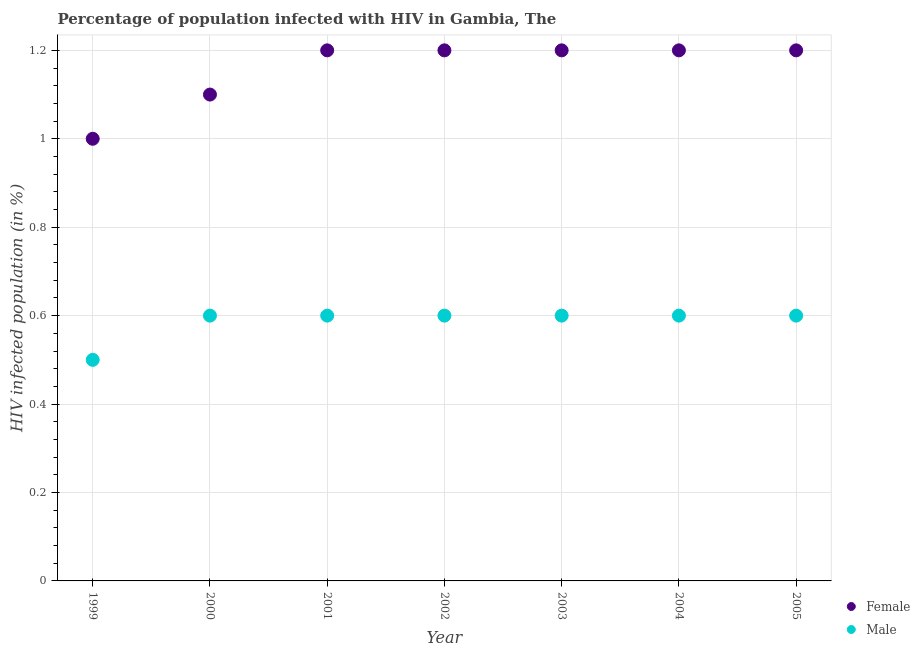How many different coloured dotlines are there?
Offer a very short reply. 2. Is the number of dotlines equal to the number of legend labels?
Offer a very short reply. Yes. In which year was the percentage of males who are infected with hiv minimum?
Make the answer very short. 1999. What is the difference between the percentage of females who are infected with hiv in 1999 and that in 2000?
Provide a succinct answer. -0.1. What is the average percentage of males who are infected with hiv per year?
Offer a very short reply. 0.59. What is the difference between the highest and the second highest percentage of females who are infected with hiv?
Provide a succinct answer. 0. What is the difference between the highest and the lowest percentage of females who are infected with hiv?
Your answer should be compact. 0.2. In how many years, is the percentage of males who are infected with hiv greater than the average percentage of males who are infected with hiv taken over all years?
Your answer should be compact. 6. Is the sum of the percentage of females who are infected with hiv in 1999 and 2000 greater than the maximum percentage of males who are infected with hiv across all years?
Your answer should be compact. Yes. Is the percentage of females who are infected with hiv strictly greater than the percentage of males who are infected with hiv over the years?
Your response must be concise. Yes. How many dotlines are there?
Ensure brevity in your answer.  2. Does the graph contain grids?
Give a very brief answer. Yes. Where does the legend appear in the graph?
Your response must be concise. Bottom right. How many legend labels are there?
Keep it short and to the point. 2. What is the title of the graph?
Offer a very short reply. Percentage of population infected with HIV in Gambia, The. Does "Food" appear as one of the legend labels in the graph?
Offer a terse response. No. What is the label or title of the X-axis?
Offer a very short reply. Year. What is the label or title of the Y-axis?
Keep it short and to the point. HIV infected population (in %). What is the HIV infected population (in %) of Male in 2001?
Ensure brevity in your answer.  0.6. What is the HIV infected population (in %) in Female in 2002?
Offer a very short reply. 1.2. What is the HIV infected population (in %) of Male in 2002?
Provide a succinct answer. 0.6. What is the HIV infected population (in %) in Female in 2003?
Provide a succinct answer. 1.2. What is the HIV infected population (in %) of Male in 2003?
Provide a short and direct response. 0.6. What is the HIV infected population (in %) in Male in 2004?
Ensure brevity in your answer.  0.6. Across all years, what is the maximum HIV infected population (in %) in Male?
Offer a terse response. 0.6. Across all years, what is the minimum HIV infected population (in %) of Female?
Provide a short and direct response. 1. What is the total HIV infected population (in %) of Female in the graph?
Your response must be concise. 8.1. What is the total HIV infected population (in %) in Male in the graph?
Your answer should be compact. 4.1. What is the difference between the HIV infected population (in %) in Female in 1999 and that in 2000?
Give a very brief answer. -0.1. What is the difference between the HIV infected population (in %) in Male in 1999 and that in 2000?
Give a very brief answer. -0.1. What is the difference between the HIV infected population (in %) of Female in 1999 and that in 2001?
Your response must be concise. -0.2. What is the difference between the HIV infected population (in %) in Male in 1999 and that in 2001?
Your answer should be very brief. -0.1. What is the difference between the HIV infected population (in %) of Male in 1999 and that in 2002?
Offer a terse response. -0.1. What is the difference between the HIV infected population (in %) of Female in 1999 and that in 2003?
Ensure brevity in your answer.  -0.2. What is the difference between the HIV infected population (in %) of Male in 1999 and that in 2003?
Your answer should be very brief. -0.1. What is the difference between the HIV infected population (in %) of Female in 1999 and that in 2004?
Provide a succinct answer. -0.2. What is the difference between the HIV infected population (in %) in Male in 1999 and that in 2004?
Offer a terse response. -0.1. What is the difference between the HIV infected population (in %) in Female in 1999 and that in 2005?
Your response must be concise. -0.2. What is the difference between the HIV infected population (in %) in Female in 2000 and that in 2002?
Provide a short and direct response. -0.1. What is the difference between the HIV infected population (in %) in Male in 2000 and that in 2002?
Provide a short and direct response. 0. What is the difference between the HIV infected population (in %) in Male in 2000 and that in 2004?
Ensure brevity in your answer.  0. What is the difference between the HIV infected population (in %) of Male in 2000 and that in 2005?
Offer a very short reply. 0. What is the difference between the HIV infected population (in %) of Female in 2001 and that in 2003?
Provide a short and direct response. 0. What is the difference between the HIV infected population (in %) in Male in 2001 and that in 2003?
Your answer should be compact. 0. What is the difference between the HIV infected population (in %) of Male in 2001 and that in 2004?
Provide a succinct answer. 0. What is the difference between the HIV infected population (in %) of Female in 2001 and that in 2005?
Keep it short and to the point. 0. What is the difference between the HIV infected population (in %) of Male in 2001 and that in 2005?
Keep it short and to the point. 0. What is the difference between the HIV infected population (in %) of Male in 2002 and that in 2003?
Make the answer very short. 0. What is the difference between the HIV infected population (in %) in Female in 2002 and that in 2004?
Keep it short and to the point. 0. What is the difference between the HIV infected population (in %) in Male in 2002 and that in 2004?
Your response must be concise. 0. What is the difference between the HIV infected population (in %) of Male in 2002 and that in 2005?
Provide a short and direct response. 0. What is the difference between the HIV infected population (in %) of Female in 2003 and that in 2004?
Offer a very short reply. 0. What is the difference between the HIV infected population (in %) of Male in 2003 and that in 2004?
Your answer should be compact. 0. What is the difference between the HIV infected population (in %) in Female in 2004 and that in 2005?
Ensure brevity in your answer.  0. What is the difference between the HIV infected population (in %) of Male in 2004 and that in 2005?
Your answer should be very brief. 0. What is the difference between the HIV infected population (in %) in Female in 1999 and the HIV infected population (in %) in Male in 2001?
Provide a succinct answer. 0.4. What is the difference between the HIV infected population (in %) of Female in 2000 and the HIV infected population (in %) of Male in 2003?
Offer a very short reply. 0.5. What is the difference between the HIV infected population (in %) in Female in 2001 and the HIV infected population (in %) in Male in 2002?
Provide a short and direct response. 0.6. What is the difference between the HIV infected population (in %) of Female in 2001 and the HIV infected population (in %) of Male in 2003?
Offer a terse response. 0.6. What is the difference between the HIV infected population (in %) in Female in 2001 and the HIV infected population (in %) in Male in 2004?
Your answer should be compact. 0.6. What is the difference between the HIV infected population (in %) of Female in 2002 and the HIV infected population (in %) of Male in 2004?
Offer a very short reply. 0.6. What is the difference between the HIV infected population (in %) of Female in 2003 and the HIV infected population (in %) of Male in 2004?
Your answer should be compact. 0.6. What is the difference between the HIV infected population (in %) of Female in 2003 and the HIV infected population (in %) of Male in 2005?
Give a very brief answer. 0.6. What is the difference between the HIV infected population (in %) of Female in 2004 and the HIV infected population (in %) of Male in 2005?
Make the answer very short. 0.6. What is the average HIV infected population (in %) of Female per year?
Your answer should be compact. 1.16. What is the average HIV infected population (in %) in Male per year?
Offer a terse response. 0.59. In the year 1999, what is the difference between the HIV infected population (in %) of Female and HIV infected population (in %) of Male?
Keep it short and to the point. 0.5. In the year 2001, what is the difference between the HIV infected population (in %) in Female and HIV infected population (in %) in Male?
Give a very brief answer. 0.6. In the year 2002, what is the difference between the HIV infected population (in %) of Female and HIV infected population (in %) of Male?
Provide a short and direct response. 0.6. In the year 2003, what is the difference between the HIV infected population (in %) of Female and HIV infected population (in %) of Male?
Offer a terse response. 0.6. In the year 2005, what is the difference between the HIV infected population (in %) in Female and HIV infected population (in %) in Male?
Your response must be concise. 0.6. What is the ratio of the HIV infected population (in %) of Female in 1999 to that in 2000?
Offer a very short reply. 0.91. What is the ratio of the HIV infected population (in %) in Male in 1999 to that in 2000?
Give a very brief answer. 0.83. What is the ratio of the HIV infected population (in %) in Female in 1999 to that in 2001?
Give a very brief answer. 0.83. What is the ratio of the HIV infected population (in %) in Male in 1999 to that in 2001?
Keep it short and to the point. 0.83. What is the ratio of the HIV infected population (in %) in Female in 1999 to that in 2002?
Your answer should be compact. 0.83. What is the ratio of the HIV infected population (in %) in Female in 1999 to that in 2003?
Provide a succinct answer. 0.83. What is the ratio of the HIV infected population (in %) of Male in 1999 to that in 2003?
Make the answer very short. 0.83. What is the ratio of the HIV infected population (in %) of Female in 1999 to that in 2005?
Give a very brief answer. 0.83. What is the ratio of the HIV infected population (in %) of Female in 2000 to that in 2001?
Ensure brevity in your answer.  0.92. What is the ratio of the HIV infected population (in %) of Male in 2000 to that in 2001?
Give a very brief answer. 1. What is the ratio of the HIV infected population (in %) of Female in 2000 to that in 2002?
Make the answer very short. 0.92. What is the ratio of the HIV infected population (in %) in Male in 2000 to that in 2002?
Offer a terse response. 1. What is the ratio of the HIV infected population (in %) in Female in 2000 to that in 2003?
Offer a terse response. 0.92. What is the ratio of the HIV infected population (in %) in Female in 2000 to that in 2004?
Your answer should be very brief. 0.92. What is the ratio of the HIV infected population (in %) in Female in 2000 to that in 2005?
Offer a very short reply. 0.92. What is the ratio of the HIV infected population (in %) of Male in 2001 to that in 2002?
Make the answer very short. 1. What is the ratio of the HIV infected population (in %) in Male in 2001 to that in 2003?
Ensure brevity in your answer.  1. What is the ratio of the HIV infected population (in %) in Male in 2001 to that in 2005?
Ensure brevity in your answer.  1. What is the ratio of the HIV infected population (in %) in Female in 2002 to that in 2004?
Provide a short and direct response. 1. What is the ratio of the HIV infected population (in %) in Male in 2002 to that in 2004?
Offer a terse response. 1. What is the ratio of the HIV infected population (in %) of Male in 2003 to that in 2005?
Keep it short and to the point. 1. What is the ratio of the HIV infected population (in %) of Female in 2004 to that in 2005?
Ensure brevity in your answer.  1. What is the ratio of the HIV infected population (in %) of Male in 2004 to that in 2005?
Your answer should be compact. 1. What is the difference between the highest and the second highest HIV infected population (in %) of Male?
Your answer should be very brief. 0. What is the difference between the highest and the lowest HIV infected population (in %) in Male?
Keep it short and to the point. 0.1. 